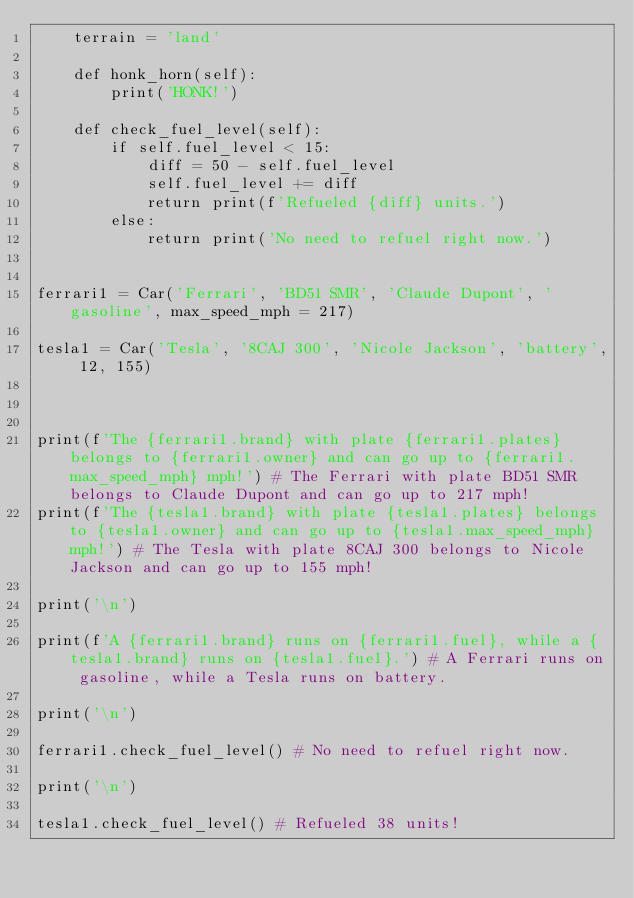Convert code to text. <code><loc_0><loc_0><loc_500><loc_500><_Python_>    terrain = 'land'

    def honk_horn(self):
        print('HONK!')
        
    def check_fuel_level(self):
        if self.fuel_level < 15:
            diff = 50 - self.fuel_level
            self.fuel_level += diff
            return print(f'Refueled {diff} units.')
        else:
            return print('No need to refuel right now.')


ferrari1 = Car('Ferrari', 'BD51 SMR', 'Claude Dupont', 'gasoline', max_speed_mph = 217)

tesla1 = Car('Tesla', '8CAJ 300', 'Nicole Jackson', 'battery', 12, 155)



print(f'The {ferrari1.brand} with plate {ferrari1.plates} belongs to {ferrari1.owner} and can go up to {ferrari1.max_speed_mph} mph!') # The Ferrari with plate BD51 SMR belongs to Claude Dupont and can go up to 217 mph!
print(f'The {tesla1.brand} with plate {tesla1.plates} belongs to {tesla1.owner} and can go up to {tesla1.max_speed_mph} mph!') # The Tesla with plate 8CAJ 300 belongs to Nicole Jackson and can go up to 155 mph!

print('\n')

print(f'A {ferrari1.brand} runs on {ferrari1.fuel}, while a {tesla1.brand} runs on {tesla1.fuel}.') # A Ferrari runs on gasoline, while a Tesla runs on battery.

print('\n')

ferrari1.check_fuel_level() # No need to refuel right now.

print('\n')

tesla1.check_fuel_level() # Refueled 38 units!

</code> 